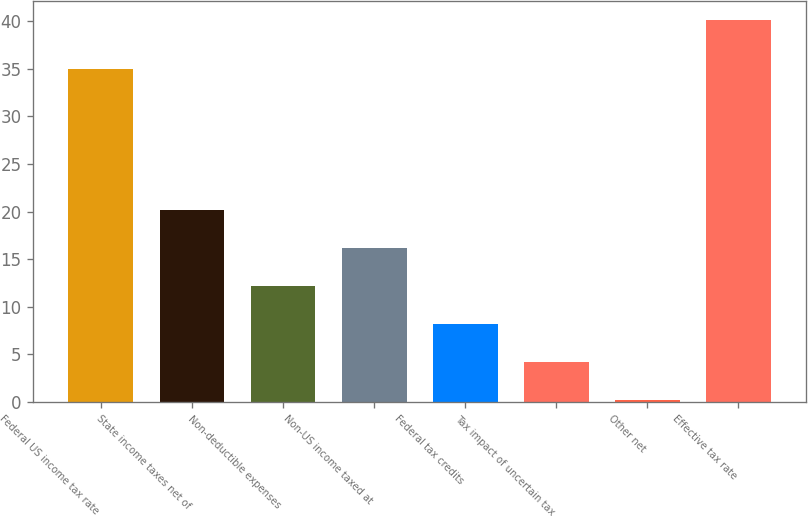<chart> <loc_0><loc_0><loc_500><loc_500><bar_chart><fcel>Federal US income tax rate<fcel>State income taxes net of<fcel>Non-deductible expenses<fcel>Non-US income taxed at<fcel>Federal tax credits<fcel>Tax impact of uncertain tax<fcel>Other net<fcel>Effective tax rate<nl><fcel>35<fcel>20.15<fcel>12.17<fcel>16.16<fcel>8.18<fcel>4.19<fcel>0.2<fcel>40.1<nl></chart> 